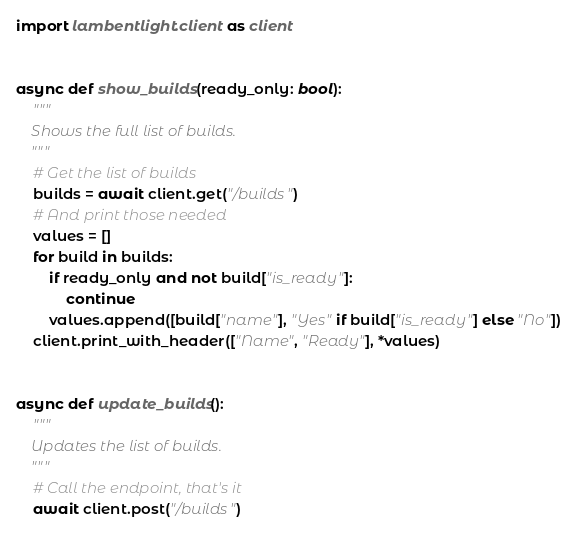<code> <loc_0><loc_0><loc_500><loc_500><_Python_>import lambentlight.client as client


async def show_builds(ready_only: bool):
    """
    Shows the full list of builds.
    """
    # Get the list of builds
    builds = await client.get("/builds")
    # And print those needed
    values = []
    for build in builds:
        if ready_only and not build["is_ready"]:
            continue
        values.append([build["name"], "Yes" if build["is_ready"] else "No"])
    client.print_with_header(["Name", "Ready"], *values)


async def update_builds():
    """
    Updates the list of builds.
    """
    # Call the endpoint, that's it
    await client.post("/builds")
</code> 